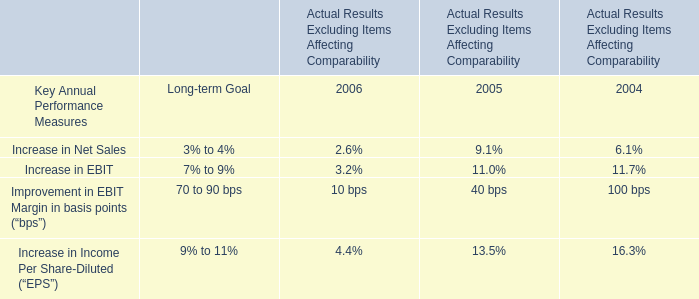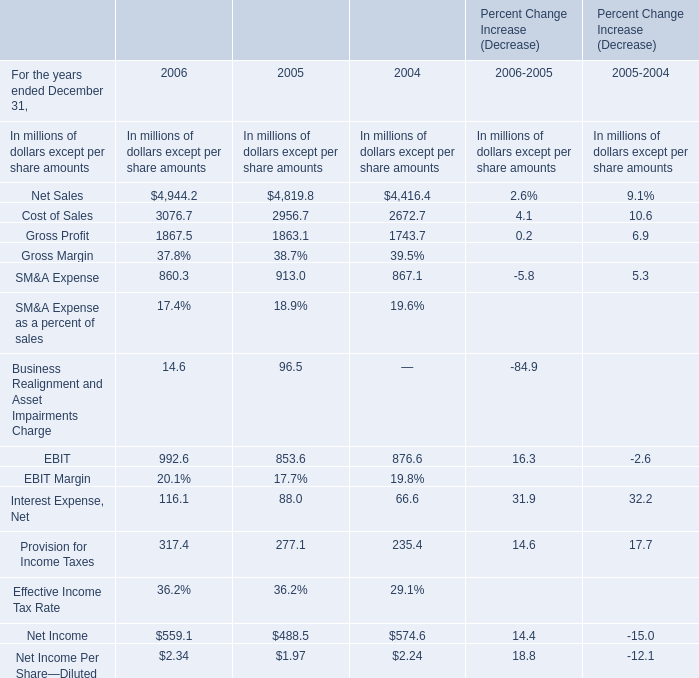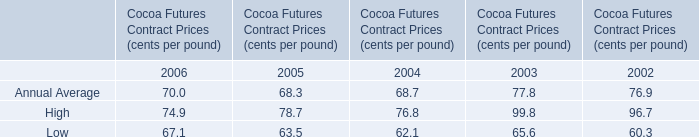In the year with lowest amount of High in Table 2, what's the increasing rate of Gross Profit in Table 1? 
Computations: ((1867.5 - 1863.1) / 1863.1)
Answer: 0.00236. 